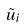Convert formula to latex. <formula><loc_0><loc_0><loc_500><loc_500>\tilde { u } _ { i }</formula> 